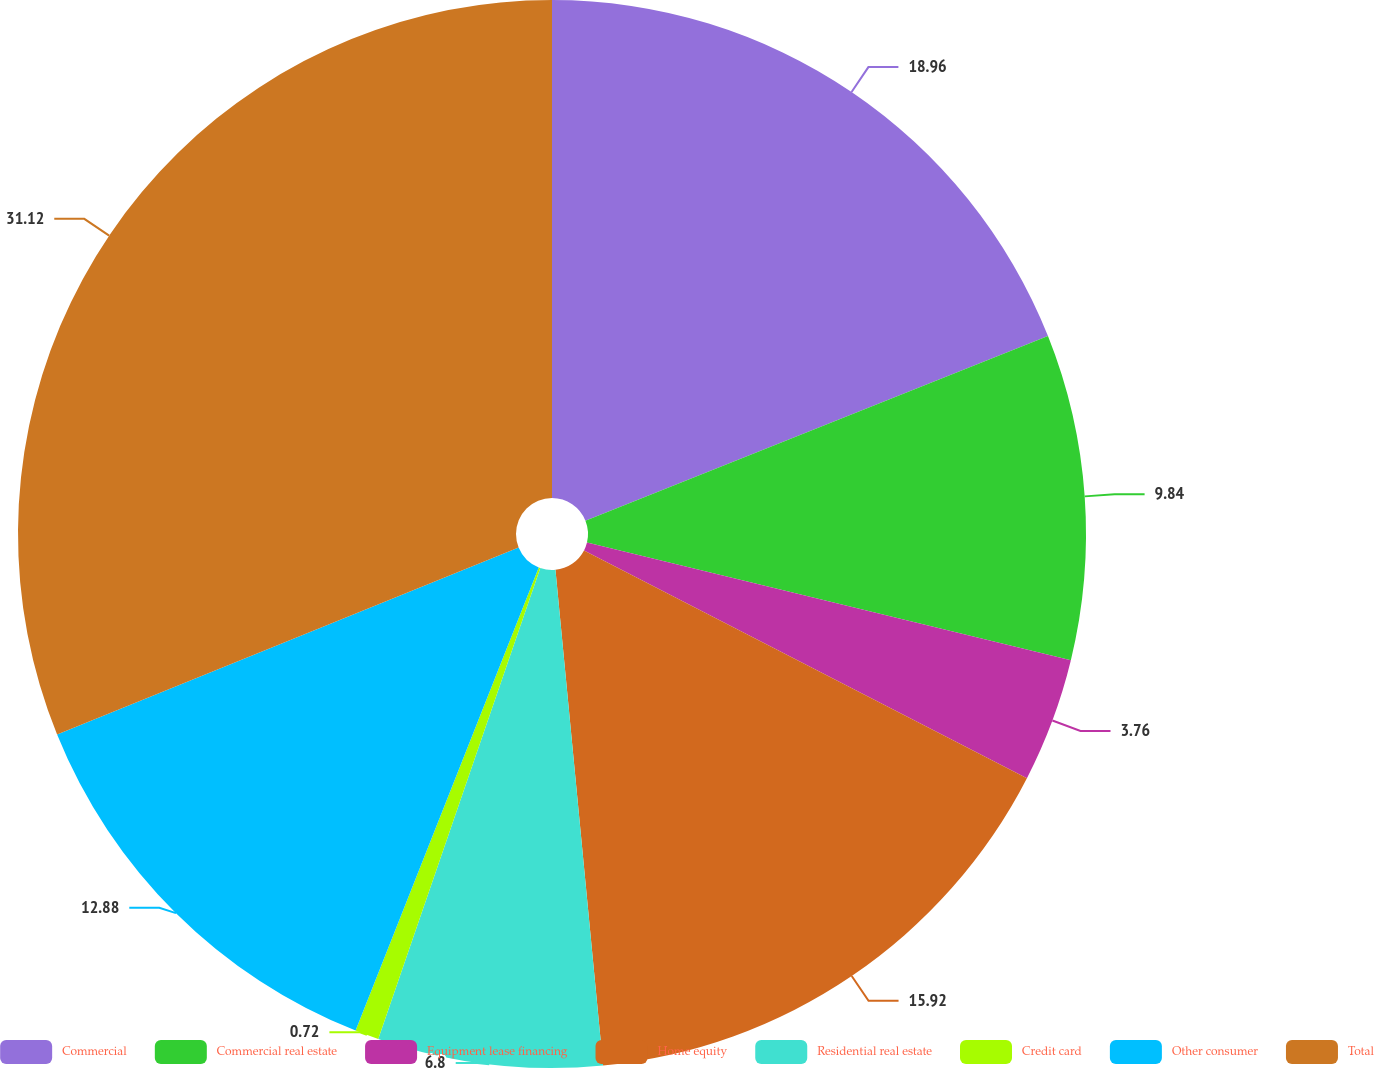Convert chart to OTSL. <chart><loc_0><loc_0><loc_500><loc_500><pie_chart><fcel>Commercial<fcel>Commercial real estate<fcel>Equipment lease financing<fcel>Home equity<fcel>Residential real estate<fcel>Credit card<fcel>Other consumer<fcel>Total<nl><fcel>18.96%<fcel>9.84%<fcel>3.76%<fcel>15.92%<fcel>6.8%<fcel>0.72%<fcel>12.88%<fcel>31.13%<nl></chart> 